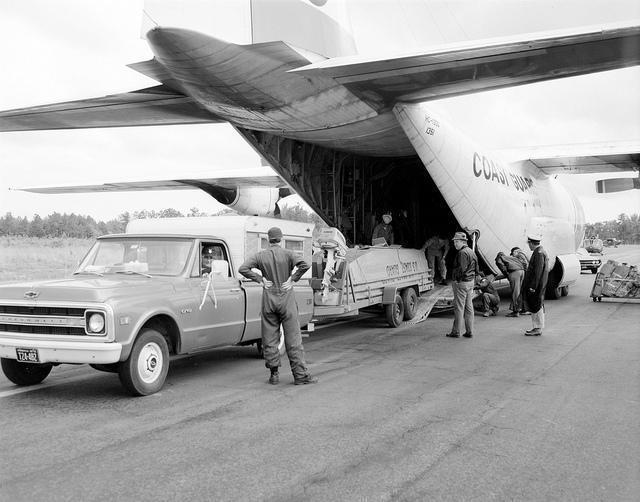How many people are there?
Give a very brief answer. 2. How many blue umbrellas are in the image?
Give a very brief answer. 0. 